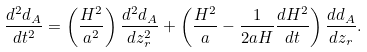<formula> <loc_0><loc_0><loc_500><loc_500>\frac { d ^ { 2 } d _ { A } } { d t ^ { 2 } } = \left ( \frac { H ^ { 2 } } { a ^ { 2 } } \right ) \frac { d ^ { 2 } d _ { A } } { d z _ { r } ^ { 2 } } + \left ( \frac { H ^ { 2 } } { a } - \frac { 1 } { 2 a H } \frac { d H ^ { 2 } } { d t } \right ) \frac { d d _ { A } } { d z _ { r } } .</formula> 